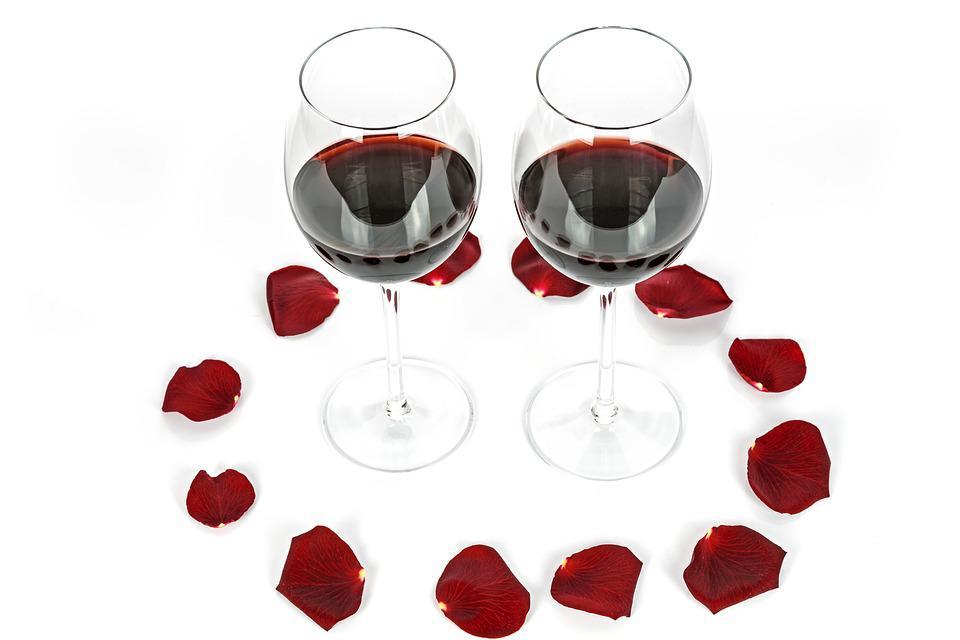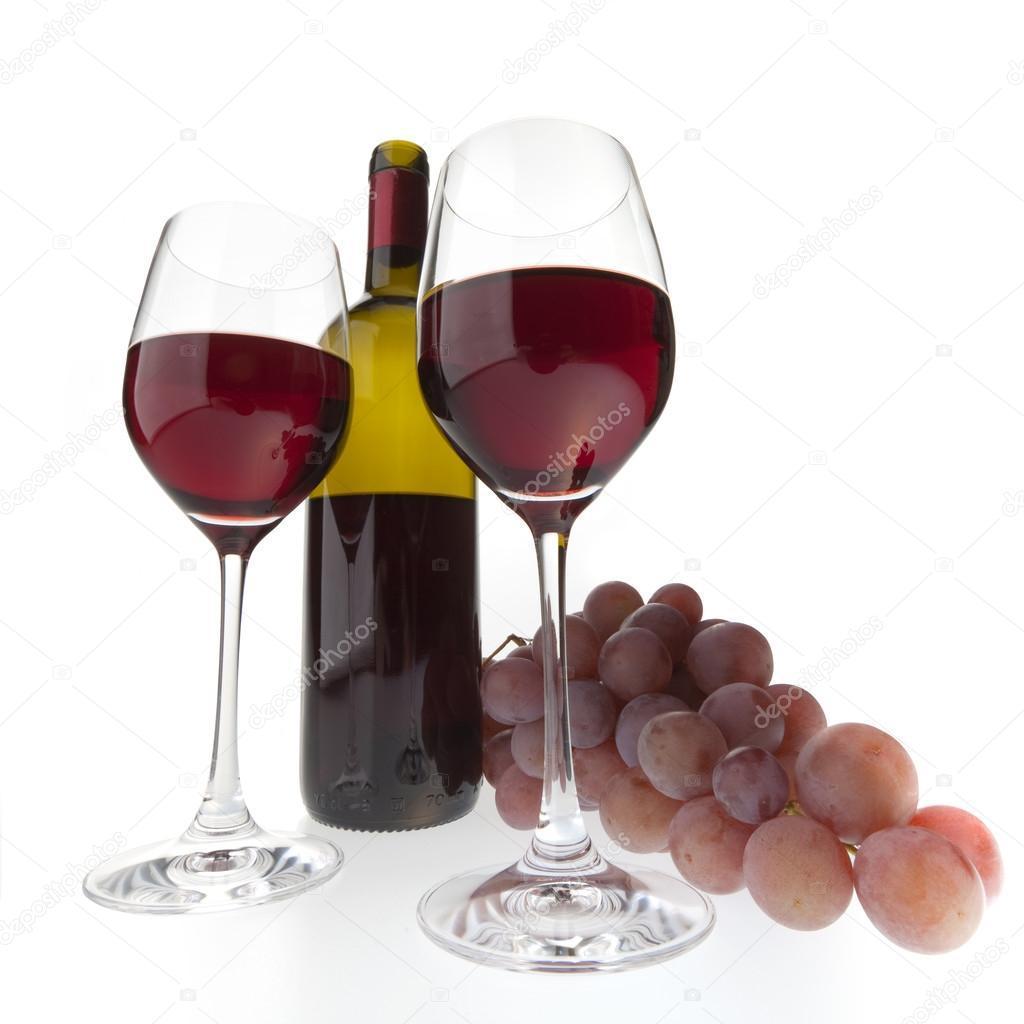The first image is the image on the left, the second image is the image on the right. Assess this claim about the two images: "Wine is being poured in a wine glass in one of the images.". Correct or not? Answer yes or no. No. The first image is the image on the left, the second image is the image on the right. For the images displayed, is the sentence "An image includes two glasses of wine, at least one bunch of grapes, and one wine bottle." factually correct? Answer yes or no. Yes. 